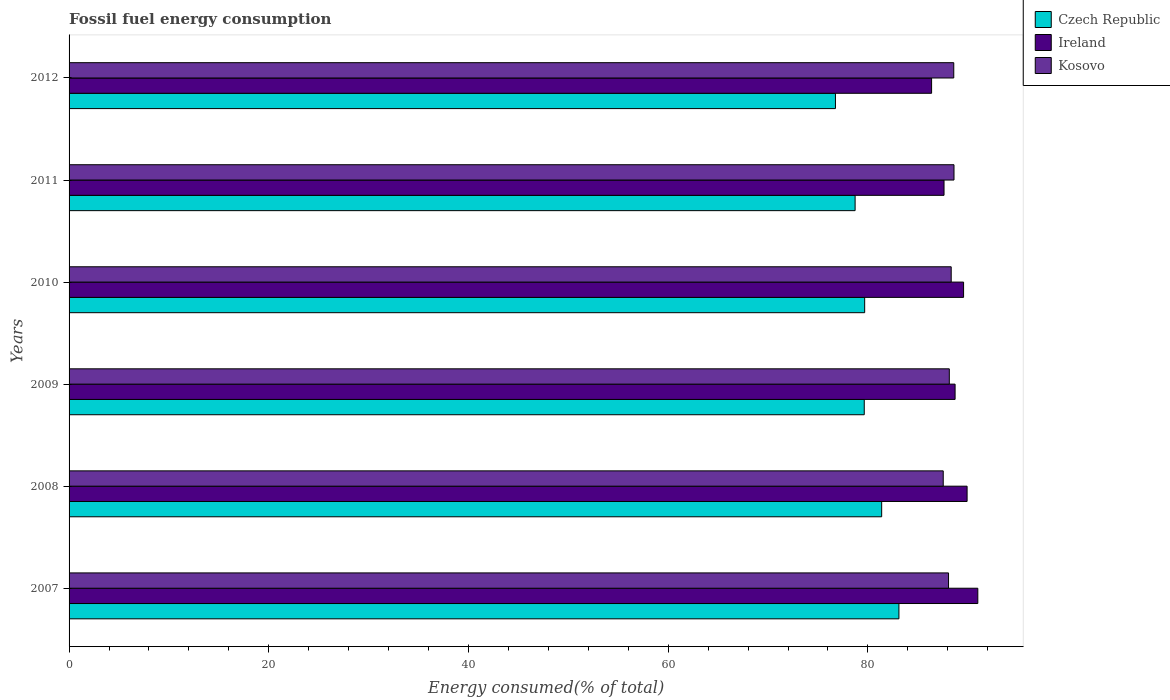How many different coloured bars are there?
Offer a terse response. 3. How many bars are there on the 1st tick from the top?
Keep it short and to the point. 3. How many bars are there on the 4th tick from the bottom?
Give a very brief answer. 3. What is the label of the 6th group of bars from the top?
Offer a terse response. 2007. What is the percentage of energy consumed in Czech Republic in 2010?
Give a very brief answer. 79.68. Across all years, what is the maximum percentage of energy consumed in Ireland?
Your response must be concise. 91. Across all years, what is the minimum percentage of energy consumed in Ireland?
Your response must be concise. 86.38. In which year was the percentage of energy consumed in Czech Republic minimum?
Ensure brevity in your answer.  2012. What is the total percentage of energy consumed in Ireland in the graph?
Offer a terse response. 533.25. What is the difference between the percentage of energy consumed in Ireland in 2007 and that in 2008?
Your response must be concise. 1.07. What is the difference between the percentage of energy consumed in Kosovo in 2010 and the percentage of energy consumed in Czech Republic in 2011?
Provide a short and direct response. 9.62. What is the average percentage of energy consumed in Ireland per year?
Make the answer very short. 88.87. In the year 2007, what is the difference between the percentage of energy consumed in Kosovo and percentage of energy consumed in Ireland?
Your answer should be very brief. -2.93. In how many years, is the percentage of energy consumed in Kosovo greater than 12 %?
Offer a terse response. 6. What is the ratio of the percentage of energy consumed in Czech Republic in 2009 to that in 2011?
Your response must be concise. 1.01. What is the difference between the highest and the second highest percentage of energy consumed in Kosovo?
Give a very brief answer. 0.02. What is the difference between the highest and the lowest percentage of energy consumed in Kosovo?
Ensure brevity in your answer.  1.08. What does the 3rd bar from the top in 2010 represents?
Provide a short and direct response. Czech Republic. What does the 2nd bar from the bottom in 2010 represents?
Your answer should be compact. Ireland. How many bars are there?
Keep it short and to the point. 18. Are all the bars in the graph horizontal?
Provide a succinct answer. Yes. How many years are there in the graph?
Make the answer very short. 6. Are the values on the major ticks of X-axis written in scientific E-notation?
Make the answer very short. No. Does the graph contain any zero values?
Make the answer very short. No. Where does the legend appear in the graph?
Your answer should be compact. Top right. What is the title of the graph?
Provide a succinct answer. Fossil fuel energy consumption. Does "Jamaica" appear as one of the legend labels in the graph?
Provide a succinct answer. No. What is the label or title of the X-axis?
Your answer should be very brief. Energy consumed(% of total). What is the label or title of the Y-axis?
Provide a short and direct response. Years. What is the Energy consumed(% of total) of Czech Republic in 2007?
Your answer should be very brief. 83.11. What is the Energy consumed(% of total) in Ireland in 2007?
Keep it short and to the point. 91. What is the Energy consumed(% of total) of Kosovo in 2007?
Offer a very short reply. 88.07. What is the Energy consumed(% of total) in Czech Republic in 2008?
Make the answer very short. 81.38. What is the Energy consumed(% of total) of Ireland in 2008?
Ensure brevity in your answer.  89.93. What is the Energy consumed(% of total) in Kosovo in 2008?
Give a very brief answer. 87.54. What is the Energy consumed(% of total) in Czech Republic in 2009?
Provide a short and direct response. 79.63. What is the Energy consumed(% of total) in Ireland in 2009?
Offer a very short reply. 88.73. What is the Energy consumed(% of total) of Kosovo in 2009?
Offer a very short reply. 88.15. What is the Energy consumed(% of total) of Czech Republic in 2010?
Keep it short and to the point. 79.68. What is the Energy consumed(% of total) of Ireland in 2010?
Offer a very short reply. 89.58. What is the Energy consumed(% of total) of Kosovo in 2010?
Offer a terse response. 88.34. What is the Energy consumed(% of total) of Czech Republic in 2011?
Your answer should be very brief. 78.72. What is the Energy consumed(% of total) of Ireland in 2011?
Ensure brevity in your answer.  87.62. What is the Energy consumed(% of total) of Kosovo in 2011?
Ensure brevity in your answer.  88.62. What is the Energy consumed(% of total) in Czech Republic in 2012?
Offer a very short reply. 76.75. What is the Energy consumed(% of total) in Ireland in 2012?
Your answer should be compact. 86.38. What is the Energy consumed(% of total) of Kosovo in 2012?
Provide a short and direct response. 88.6. Across all years, what is the maximum Energy consumed(% of total) in Czech Republic?
Your answer should be compact. 83.11. Across all years, what is the maximum Energy consumed(% of total) in Ireland?
Make the answer very short. 91. Across all years, what is the maximum Energy consumed(% of total) of Kosovo?
Your answer should be compact. 88.62. Across all years, what is the minimum Energy consumed(% of total) of Czech Republic?
Offer a very short reply. 76.75. Across all years, what is the minimum Energy consumed(% of total) in Ireland?
Offer a very short reply. 86.38. Across all years, what is the minimum Energy consumed(% of total) in Kosovo?
Keep it short and to the point. 87.54. What is the total Energy consumed(% of total) of Czech Republic in the graph?
Give a very brief answer. 479.26. What is the total Energy consumed(% of total) in Ireland in the graph?
Make the answer very short. 533.25. What is the total Energy consumed(% of total) of Kosovo in the graph?
Your answer should be compact. 529.33. What is the difference between the Energy consumed(% of total) in Czech Republic in 2007 and that in 2008?
Ensure brevity in your answer.  1.73. What is the difference between the Energy consumed(% of total) in Ireland in 2007 and that in 2008?
Make the answer very short. 1.07. What is the difference between the Energy consumed(% of total) in Kosovo in 2007 and that in 2008?
Offer a very short reply. 0.53. What is the difference between the Energy consumed(% of total) in Czech Republic in 2007 and that in 2009?
Offer a terse response. 3.47. What is the difference between the Energy consumed(% of total) of Ireland in 2007 and that in 2009?
Your answer should be compact. 2.27. What is the difference between the Energy consumed(% of total) in Kosovo in 2007 and that in 2009?
Your answer should be compact. -0.08. What is the difference between the Energy consumed(% of total) in Czech Republic in 2007 and that in 2010?
Provide a succinct answer. 3.43. What is the difference between the Energy consumed(% of total) of Ireland in 2007 and that in 2010?
Give a very brief answer. 1.43. What is the difference between the Energy consumed(% of total) of Kosovo in 2007 and that in 2010?
Offer a terse response. -0.27. What is the difference between the Energy consumed(% of total) of Czech Republic in 2007 and that in 2011?
Offer a very short reply. 4.39. What is the difference between the Energy consumed(% of total) in Ireland in 2007 and that in 2011?
Ensure brevity in your answer.  3.38. What is the difference between the Energy consumed(% of total) in Kosovo in 2007 and that in 2011?
Your answer should be very brief. -0.55. What is the difference between the Energy consumed(% of total) of Czech Republic in 2007 and that in 2012?
Make the answer very short. 6.36. What is the difference between the Energy consumed(% of total) in Ireland in 2007 and that in 2012?
Provide a short and direct response. 4.63. What is the difference between the Energy consumed(% of total) of Kosovo in 2007 and that in 2012?
Keep it short and to the point. -0.52. What is the difference between the Energy consumed(% of total) in Czech Republic in 2008 and that in 2009?
Make the answer very short. 1.74. What is the difference between the Energy consumed(% of total) in Ireland in 2008 and that in 2009?
Ensure brevity in your answer.  1.2. What is the difference between the Energy consumed(% of total) in Kosovo in 2008 and that in 2009?
Provide a succinct answer. -0.61. What is the difference between the Energy consumed(% of total) of Czech Republic in 2008 and that in 2010?
Ensure brevity in your answer.  1.7. What is the difference between the Energy consumed(% of total) of Ireland in 2008 and that in 2010?
Your answer should be very brief. 0.35. What is the difference between the Energy consumed(% of total) of Kosovo in 2008 and that in 2010?
Provide a succinct answer. -0.8. What is the difference between the Energy consumed(% of total) in Czech Republic in 2008 and that in 2011?
Provide a succinct answer. 2.66. What is the difference between the Energy consumed(% of total) of Ireland in 2008 and that in 2011?
Ensure brevity in your answer.  2.31. What is the difference between the Energy consumed(% of total) of Kosovo in 2008 and that in 2011?
Your answer should be compact. -1.08. What is the difference between the Energy consumed(% of total) of Czech Republic in 2008 and that in 2012?
Your answer should be compact. 4.63. What is the difference between the Energy consumed(% of total) of Ireland in 2008 and that in 2012?
Provide a succinct answer. 3.56. What is the difference between the Energy consumed(% of total) of Kosovo in 2008 and that in 2012?
Provide a succinct answer. -1.05. What is the difference between the Energy consumed(% of total) in Czech Republic in 2009 and that in 2010?
Offer a very short reply. -0.04. What is the difference between the Energy consumed(% of total) of Ireland in 2009 and that in 2010?
Offer a very short reply. -0.85. What is the difference between the Energy consumed(% of total) of Kosovo in 2009 and that in 2010?
Your answer should be compact. -0.19. What is the difference between the Energy consumed(% of total) in Czech Republic in 2009 and that in 2011?
Your answer should be very brief. 0.92. What is the difference between the Energy consumed(% of total) of Ireland in 2009 and that in 2011?
Keep it short and to the point. 1.11. What is the difference between the Energy consumed(% of total) in Kosovo in 2009 and that in 2011?
Offer a very short reply. -0.47. What is the difference between the Energy consumed(% of total) of Czech Republic in 2009 and that in 2012?
Provide a succinct answer. 2.88. What is the difference between the Energy consumed(% of total) of Ireland in 2009 and that in 2012?
Provide a succinct answer. 2.35. What is the difference between the Energy consumed(% of total) of Kosovo in 2009 and that in 2012?
Provide a succinct answer. -0.45. What is the difference between the Energy consumed(% of total) of Czech Republic in 2010 and that in 2011?
Your answer should be compact. 0.96. What is the difference between the Energy consumed(% of total) in Ireland in 2010 and that in 2011?
Provide a succinct answer. 1.96. What is the difference between the Energy consumed(% of total) of Kosovo in 2010 and that in 2011?
Provide a short and direct response. -0.28. What is the difference between the Energy consumed(% of total) of Czech Republic in 2010 and that in 2012?
Your answer should be compact. 2.93. What is the difference between the Energy consumed(% of total) in Ireland in 2010 and that in 2012?
Make the answer very short. 3.2. What is the difference between the Energy consumed(% of total) of Kosovo in 2010 and that in 2012?
Provide a short and direct response. -0.26. What is the difference between the Energy consumed(% of total) of Czech Republic in 2011 and that in 2012?
Keep it short and to the point. 1.97. What is the difference between the Energy consumed(% of total) of Ireland in 2011 and that in 2012?
Make the answer very short. 1.25. What is the difference between the Energy consumed(% of total) in Kosovo in 2011 and that in 2012?
Keep it short and to the point. 0.02. What is the difference between the Energy consumed(% of total) of Czech Republic in 2007 and the Energy consumed(% of total) of Ireland in 2008?
Offer a very short reply. -6.83. What is the difference between the Energy consumed(% of total) of Czech Republic in 2007 and the Energy consumed(% of total) of Kosovo in 2008?
Your response must be concise. -4.44. What is the difference between the Energy consumed(% of total) in Ireland in 2007 and the Energy consumed(% of total) in Kosovo in 2008?
Your answer should be compact. 3.46. What is the difference between the Energy consumed(% of total) of Czech Republic in 2007 and the Energy consumed(% of total) of Ireland in 2009?
Your answer should be very brief. -5.62. What is the difference between the Energy consumed(% of total) of Czech Republic in 2007 and the Energy consumed(% of total) of Kosovo in 2009?
Ensure brevity in your answer.  -5.05. What is the difference between the Energy consumed(% of total) in Ireland in 2007 and the Energy consumed(% of total) in Kosovo in 2009?
Make the answer very short. 2.85. What is the difference between the Energy consumed(% of total) in Czech Republic in 2007 and the Energy consumed(% of total) in Ireland in 2010?
Your response must be concise. -6.47. What is the difference between the Energy consumed(% of total) in Czech Republic in 2007 and the Energy consumed(% of total) in Kosovo in 2010?
Offer a terse response. -5.24. What is the difference between the Energy consumed(% of total) in Ireland in 2007 and the Energy consumed(% of total) in Kosovo in 2010?
Ensure brevity in your answer.  2.66. What is the difference between the Energy consumed(% of total) of Czech Republic in 2007 and the Energy consumed(% of total) of Ireland in 2011?
Offer a terse response. -4.52. What is the difference between the Energy consumed(% of total) of Czech Republic in 2007 and the Energy consumed(% of total) of Kosovo in 2011?
Provide a succinct answer. -5.52. What is the difference between the Energy consumed(% of total) in Ireland in 2007 and the Energy consumed(% of total) in Kosovo in 2011?
Your response must be concise. 2.38. What is the difference between the Energy consumed(% of total) in Czech Republic in 2007 and the Energy consumed(% of total) in Ireland in 2012?
Provide a succinct answer. -3.27. What is the difference between the Energy consumed(% of total) of Czech Republic in 2007 and the Energy consumed(% of total) of Kosovo in 2012?
Make the answer very short. -5.49. What is the difference between the Energy consumed(% of total) in Ireland in 2007 and the Energy consumed(% of total) in Kosovo in 2012?
Offer a very short reply. 2.41. What is the difference between the Energy consumed(% of total) of Czech Republic in 2008 and the Energy consumed(% of total) of Ireland in 2009?
Make the answer very short. -7.35. What is the difference between the Energy consumed(% of total) of Czech Republic in 2008 and the Energy consumed(% of total) of Kosovo in 2009?
Ensure brevity in your answer.  -6.77. What is the difference between the Energy consumed(% of total) of Ireland in 2008 and the Energy consumed(% of total) of Kosovo in 2009?
Give a very brief answer. 1.78. What is the difference between the Energy consumed(% of total) in Czech Republic in 2008 and the Energy consumed(% of total) in Ireland in 2010?
Offer a terse response. -8.2. What is the difference between the Energy consumed(% of total) of Czech Republic in 2008 and the Energy consumed(% of total) of Kosovo in 2010?
Provide a short and direct response. -6.96. What is the difference between the Energy consumed(% of total) of Ireland in 2008 and the Energy consumed(% of total) of Kosovo in 2010?
Your response must be concise. 1.59. What is the difference between the Energy consumed(% of total) of Czech Republic in 2008 and the Energy consumed(% of total) of Ireland in 2011?
Offer a terse response. -6.25. What is the difference between the Energy consumed(% of total) in Czech Republic in 2008 and the Energy consumed(% of total) in Kosovo in 2011?
Offer a terse response. -7.24. What is the difference between the Energy consumed(% of total) of Ireland in 2008 and the Energy consumed(% of total) of Kosovo in 2011?
Give a very brief answer. 1.31. What is the difference between the Energy consumed(% of total) in Czech Republic in 2008 and the Energy consumed(% of total) in Ireland in 2012?
Keep it short and to the point. -5. What is the difference between the Energy consumed(% of total) of Czech Republic in 2008 and the Energy consumed(% of total) of Kosovo in 2012?
Ensure brevity in your answer.  -7.22. What is the difference between the Energy consumed(% of total) of Ireland in 2008 and the Energy consumed(% of total) of Kosovo in 2012?
Make the answer very short. 1.33. What is the difference between the Energy consumed(% of total) of Czech Republic in 2009 and the Energy consumed(% of total) of Ireland in 2010?
Ensure brevity in your answer.  -9.95. What is the difference between the Energy consumed(% of total) of Czech Republic in 2009 and the Energy consumed(% of total) of Kosovo in 2010?
Ensure brevity in your answer.  -8.71. What is the difference between the Energy consumed(% of total) of Ireland in 2009 and the Energy consumed(% of total) of Kosovo in 2010?
Make the answer very short. 0.39. What is the difference between the Energy consumed(% of total) of Czech Republic in 2009 and the Energy consumed(% of total) of Ireland in 2011?
Your answer should be very brief. -7.99. What is the difference between the Energy consumed(% of total) in Czech Republic in 2009 and the Energy consumed(% of total) in Kosovo in 2011?
Keep it short and to the point. -8.99. What is the difference between the Energy consumed(% of total) of Ireland in 2009 and the Energy consumed(% of total) of Kosovo in 2011?
Offer a terse response. 0.11. What is the difference between the Energy consumed(% of total) in Czech Republic in 2009 and the Energy consumed(% of total) in Ireland in 2012?
Keep it short and to the point. -6.74. What is the difference between the Energy consumed(% of total) of Czech Republic in 2009 and the Energy consumed(% of total) of Kosovo in 2012?
Your answer should be very brief. -8.96. What is the difference between the Energy consumed(% of total) of Ireland in 2009 and the Energy consumed(% of total) of Kosovo in 2012?
Offer a terse response. 0.13. What is the difference between the Energy consumed(% of total) of Czech Republic in 2010 and the Energy consumed(% of total) of Ireland in 2011?
Your answer should be very brief. -7.95. What is the difference between the Energy consumed(% of total) of Czech Republic in 2010 and the Energy consumed(% of total) of Kosovo in 2011?
Provide a short and direct response. -8.95. What is the difference between the Energy consumed(% of total) in Ireland in 2010 and the Energy consumed(% of total) in Kosovo in 2011?
Offer a very short reply. 0.96. What is the difference between the Energy consumed(% of total) in Czech Republic in 2010 and the Energy consumed(% of total) in Ireland in 2012?
Provide a short and direct response. -6.7. What is the difference between the Energy consumed(% of total) in Czech Republic in 2010 and the Energy consumed(% of total) in Kosovo in 2012?
Provide a succinct answer. -8.92. What is the difference between the Energy consumed(% of total) in Ireland in 2010 and the Energy consumed(% of total) in Kosovo in 2012?
Ensure brevity in your answer.  0.98. What is the difference between the Energy consumed(% of total) of Czech Republic in 2011 and the Energy consumed(% of total) of Ireland in 2012?
Your answer should be very brief. -7.66. What is the difference between the Energy consumed(% of total) in Czech Republic in 2011 and the Energy consumed(% of total) in Kosovo in 2012?
Offer a very short reply. -9.88. What is the difference between the Energy consumed(% of total) in Ireland in 2011 and the Energy consumed(% of total) in Kosovo in 2012?
Your answer should be very brief. -0.98. What is the average Energy consumed(% of total) of Czech Republic per year?
Provide a short and direct response. 79.88. What is the average Energy consumed(% of total) of Ireland per year?
Provide a succinct answer. 88.87. What is the average Energy consumed(% of total) in Kosovo per year?
Keep it short and to the point. 88.22. In the year 2007, what is the difference between the Energy consumed(% of total) in Czech Republic and Energy consumed(% of total) in Ireland?
Your answer should be compact. -7.9. In the year 2007, what is the difference between the Energy consumed(% of total) in Czech Republic and Energy consumed(% of total) in Kosovo?
Keep it short and to the point. -4.97. In the year 2007, what is the difference between the Energy consumed(% of total) in Ireland and Energy consumed(% of total) in Kosovo?
Provide a succinct answer. 2.93. In the year 2008, what is the difference between the Energy consumed(% of total) of Czech Republic and Energy consumed(% of total) of Ireland?
Offer a terse response. -8.56. In the year 2008, what is the difference between the Energy consumed(% of total) in Czech Republic and Energy consumed(% of total) in Kosovo?
Give a very brief answer. -6.17. In the year 2008, what is the difference between the Energy consumed(% of total) in Ireland and Energy consumed(% of total) in Kosovo?
Offer a very short reply. 2.39. In the year 2009, what is the difference between the Energy consumed(% of total) of Czech Republic and Energy consumed(% of total) of Ireland?
Provide a succinct answer. -9.1. In the year 2009, what is the difference between the Energy consumed(% of total) in Czech Republic and Energy consumed(% of total) in Kosovo?
Your answer should be compact. -8.52. In the year 2009, what is the difference between the Energy consumed(% of total) of Ireland and Energy consumed(% of total) of Kosovo?
Your answer should be compact. 0.58. In the year 2010, what is the difference between the Energy consumed(% of total) of Czech Republic and Energy consumed(% of total) of Ireland?
Your response must be concise. -9.9. In the year 2010, what is the difference between the Energy consumed(% of total) in Czech Republic and Energy consumed(% of total) in Kosovo?
Your answer should be very brief. -8.67. In the year 2010, what is the difference between the Energy consumed(% of total) of Ireland and Energy consumed(% of total) of Kosovo?
Your answer should be very brief. 1.24. In the year 2011, what is the difference between the Energy consumed(% of total) of Czech Republic and Energy consumed(% of total) of Ireland?
Your answer should be very brief. -8.9. In the year 2011, what is the difference between the Energy consumed(% of total) in Czech Republic and Energy consumed(% of total) in Kosovo?
Your response must be concise. -9.9. In the year 2011, what is the difference between the Energy consumed(% of total) in Ireland and Energy consumed(% of total) in Kosovo?
Offer a very short reply. -1. In the year 2012, what is the difference between the Energy consumed(% of total) in Czech Republic and Energy consumed(% of total) in Ireland?
Your response must be concise. -9.63. In the year 2012, what is the difference between the Energy consumed(% of total) in Czech Republic and Energy consumed(% of total) in Kosovo?
Make the answer very short. -11.85. In the year 2012, what is the difference between the Energy consumed(% of total) of Ireland and Energy consumed(% of total) of Kosovo?
Provide a succinct answer. -2.22. What is the ratio of the Energy consumed(% of total) of Czech Republic in 2007 to that in 2008?
Your response must be concise. 1.02. What is the ratio of the Energy consumed(% of total) of Ireland in 2007 to that in 2008?
Make the answer very short. 1.01. What is the ratio of the Energy consumed(% of total) of Kosovo in 2007 to that in 2008?
Make the answer very short. 1.01. What is the ratio of the Energy consumed(% of total) in Czech Republic in 2007 to that in 2009?
Keep it short and to the point. 1.04. What is the ratio of the Energy consumed(% of total) in Ireland in 2007 to that in 2009?
Offer a very short reply. 1.03. What is the ratio of the Energy consumed(% of total) in Czech Republic in 2007 to that in 2010?
Keep it short and to the point. 1.04. What is the ratio of the Energy consumed(% of total) in Ireland in 2007 to that in 2010?
Give a very brief answer. 1.02. What is the ratio of the Energy consumed(% of total) in Czech Republic in 2007 to that in 2011?
Your answer should be very brief. 1.06. What is the ratio of the Energy consumed(% of total) of Ireland in 2007 to that in 2011?
Keep it short and to the point. 1.04. What is the ratio of the Energy consumed(% of total) in Kosovo in 2007 to that in 2011?
Keep it short and to the point. 0.99. What is the ratio of the Energy consumed(% of total) of Czech Republic in 2007 to that in 2012?
Offer a terse response. 1.08. What is the ratio of the Energy consumed(% of total) in Ireland in 2007 to that in 2012?
Offer a terse response. 1.05. What is the ratio of the Energy consumed(% of total) of Czech Republic in 2008 to that in 2009?
Ensure brevity in your answer.  1.02. What is the ratio of the Energy consumed(% of total) of Ireland in 2008 to that in 2009?
Ensure brevity in your answer.  1.01. What is the ratio of the Energy consumed(% of total) of Kosovo in 2008 to that in 2009?
Keep it short and to the point. 0.99. What is the ratio of the Energy consumed(% of total) of Czech Republic in 2008 to that in 2010?
Offer a terse response. 1.02. What is the ratio of the Energy consumed(% of total) in Ireland in 2008 to that in 2010?
Ensure brevity in your answer.  1. What is the ratio of the Energy consumed(% of total) of Czech Republic in 2008 to that in 2011?
Provide a short and direct response. 1.03. What is the ratio of the Energy consumed(% of total) of Ireland in 2008 to that in 2011?
Offer a terse response. 1.03. What is the ratio of the Energy consumed(% of total) in Czech Republic in 2008 to that in 2012?
Give a very brief answer. 1.06. What is the ratio of the Energy consumed(% of total) in Ireland in 2008 to that in 2012?
Keep it short and to the point. 1.04. What is the ratio of the Energy consumed(% of total) of Kosovo in 2008 to that in 2012?
Your answer should be compact. 0.99. What is the ratio of the Energy consumed(% of total) in Czech Republic in 2009 to that in 2011?
Your answer should be compact. 1.01. What is the ratio of the Energy consumed(% of total) in Ireland in 2009 to that in 2011?
Ensure brevity in your answer.  1.01. What is the ratio of the Energy consumed(% of total) in Kosovo in 2009 to that in 2011?
Ensure brevity in your answer.  0.99. What is the ratio of the Energy consumed(% of total) in Czech Republic in 2009 to that in 2012?
Give a very brief answer. 1.04. What is the ratio of the Energy consumed(% of total) of Ireland in 2009 to that in 2012?
Offer a very short reply. 1.03. What is the ratio of the Energy consumed(% of total) of Kosovo in 2009 to that in 2012?
Provide a short and direct response. 0.99. What is the ratio of the Energy consumed(% of total) in Czech Republic in 2010 to that in 2011?
Your answer should be compact. 1.01. What is the ratio of the Energy consumed(% of total) in Ireland in 2010 to that in 2011?
Make the answer very short. 1.02. What is the ratio of the Energy consumed(% of total) of Kosovo in 2010 to that in 2011?
Keep it short and to the point. 1. What is the ratio of the Energy consumed(% of total) of Czech Republic in 2010 to that in 2012?
Your response must be concise. 1.04. What is the ratio of the Energy consumed(% of total) in Ireland in 2010 to that in 2012?
Ensure brevity in your answer.  1.04. What is the ratio of the Energy consumed(% of total) in Kosovo in 2010 to that in 2012?
Your answer should be compact. 1. What is the ratio of the Energy consumed(% of total) of Czech Republic in 2011 to that in 2012?
Your answer should be very brief. 1.03. What is the ratio of the Energy consumed(% of total) in Ireland in 2011 to that in 2012?
Your answer should be compact. 1.01. What is the difference between the highest and the second highest Energy consumed(% of total) of Czech Republic?
Offer a very short reply. 1.73. What is the difference between the highest and the second highest Energy consumed(% of total) of Ireland?
Offer a terse response. 1.07. What is the difference between the highest and the second highest Energy consumed(% of total) of Kosovo?
Offer a terse response. 0.02. What is the difference between the highest and the lowest Energy consumed(% of total) of Czech Republic?
Your answer should be very brief. 6.36. What is the difference between the highest and the lowest Energy consumed(% of total) of Ireland?
Provide a succinct answer. 4.63. What is the difference between the highest and the lowest Energy consumed(% of total) in Kosovo?
Your response must be concise. 1.08. 